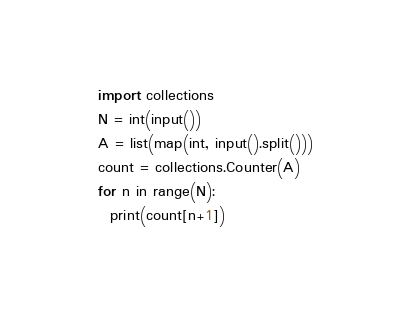<code> <loc_0><loc_0><loc_500><loc_500><_Python_>import collections
N = int(input())
A = list(map(int, input().split()))
count = collections.Counter(A)
for n in range(N):
  print(count[n+1])</code> 